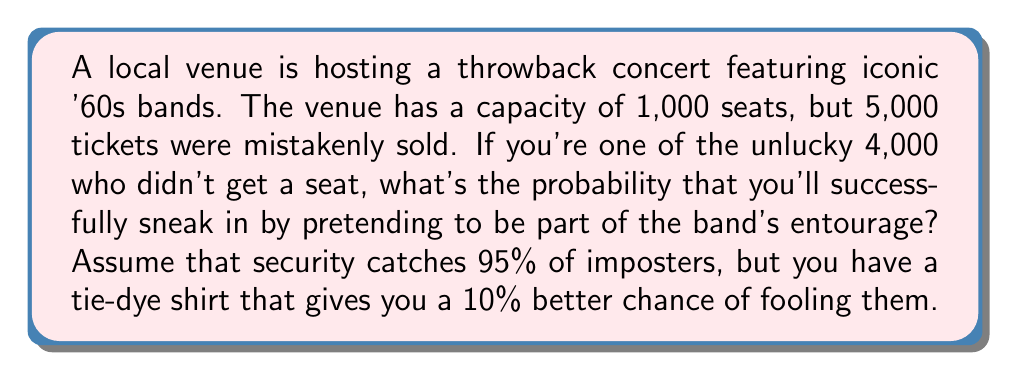Can you solve this math problem? Let's break this down step-by-step:

1) First, we need to calculate the base probability of successfully sneaking in:
   $1 - 0.95 = 0.05$ or 5%

2) Now, we account for the tie-dye shirt advantage:
   $0.05 \times 1.10 = 0.055$ or 5.5%

3) We can express this as a fraction:
   $\frac{55}{1000}$

4) To simplify this fraction, we divide both numerator and denominator by their greatest common divisor (5):
   $\frac{11}{200}$

Therefore, the probability of successfully sneaking in is $\frac{11}{200}$ or 5.5%.
Answer: $\frac{11}{200}$ 